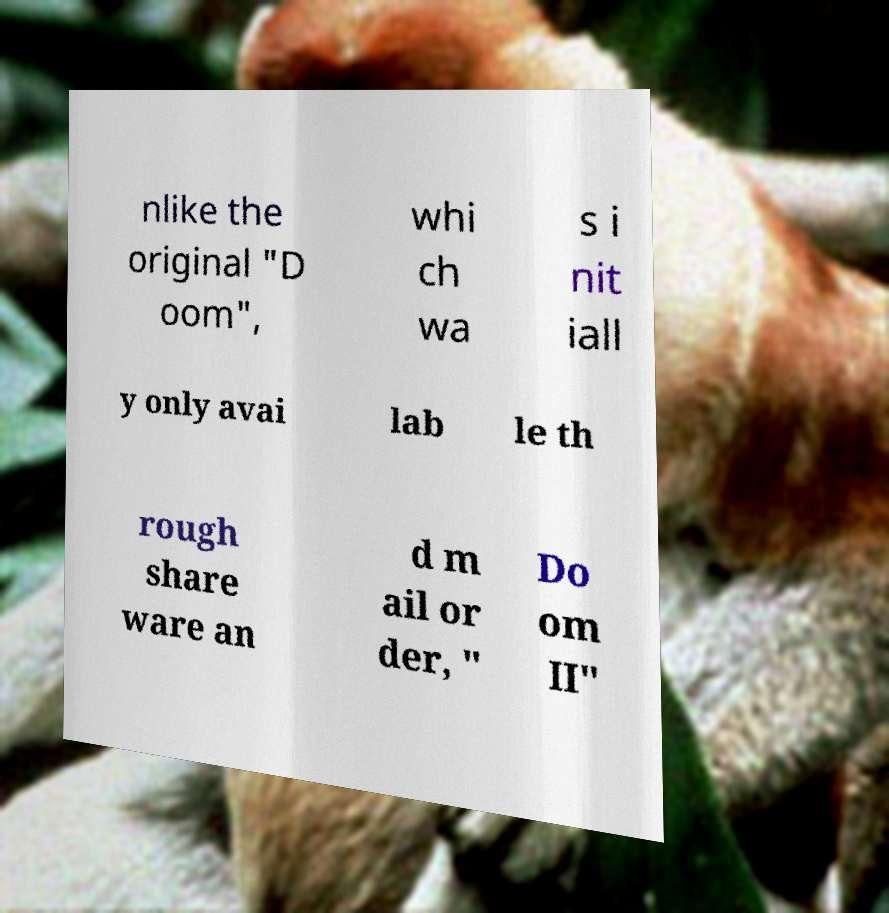Can you accurately transcribe the text from the provided image for me? nlike the original "D oom", whi ch wa s i nit iall y only avai lab le th rough share ware an d m ail or der, " Do om II" 